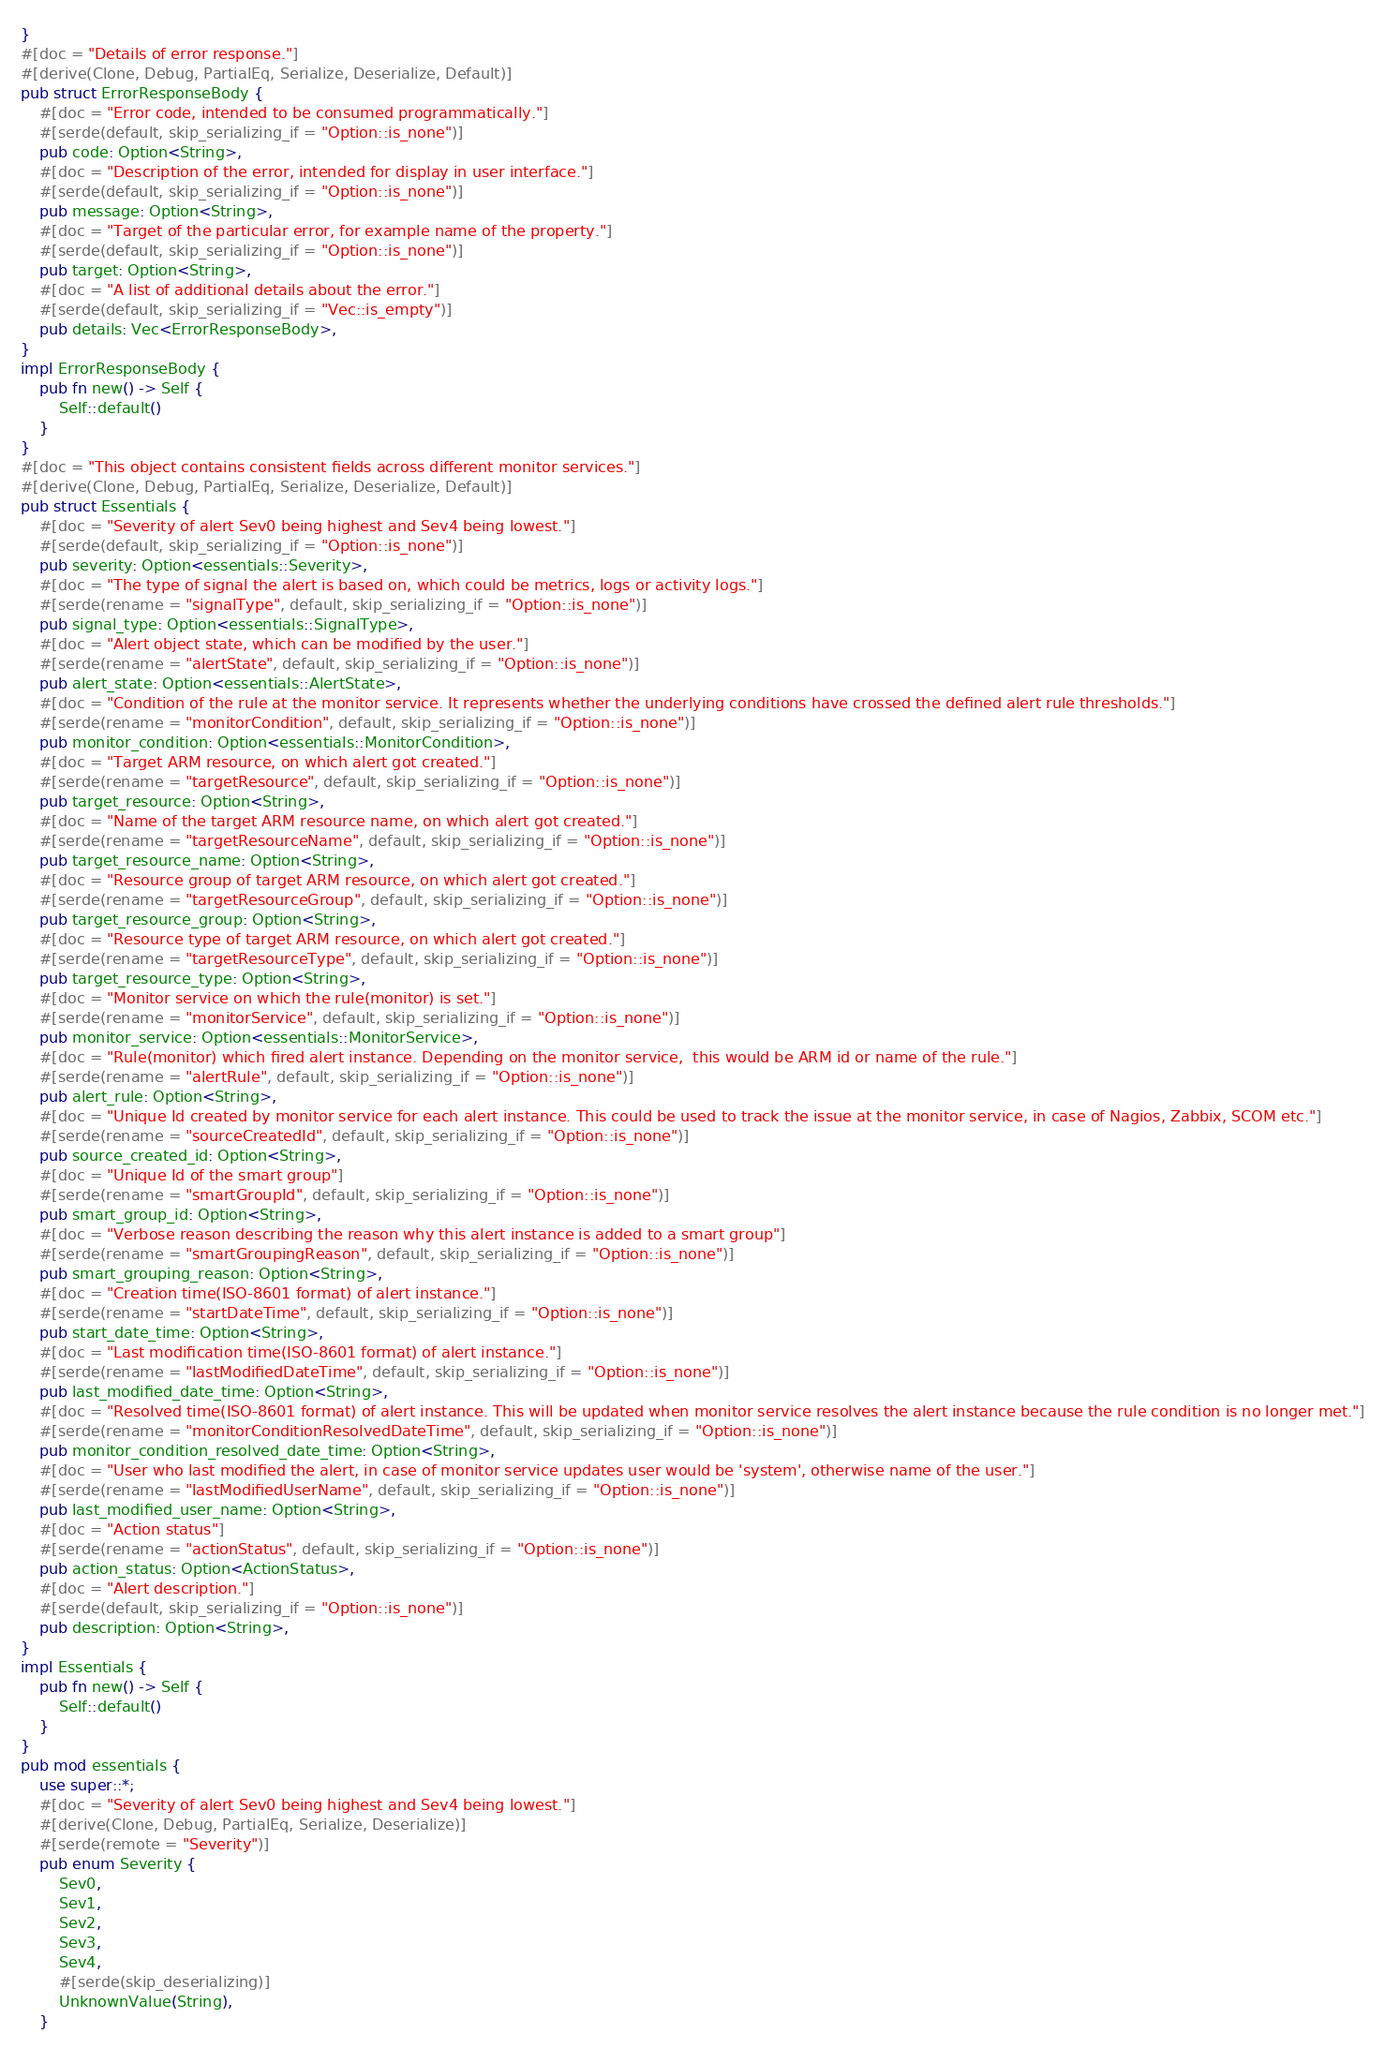<code> <loc_0><loc_0><loc_500><loc_500><_Rust_>}
#[doc = "Details of error response."]
#[derive(Clone, Debug, PartialEq, Serialize, Deserialize, Default)]
pub struct ErrorResponseBody {
    #[doc = "Error code, intended to be consumed programmatically."]
    #[serde(default, skip_serializing_if = "Option::is_none")]
    pub code: Option<String>,
    #[doc = "Description of the error, intended for display in user interface."]
    #[serde(default, skip_serializing_if = "Option::is_none")]
    pub message: Option<String>,
    #[doc = "Target of the particular error, for example name of the property."]
    #[serde(default, skip_serializing_if = "Option::is_none")]
    pub target: Option<String>,
    #[doc = "A list of additional details about the error."]
    #[serde(default, skip_serializing_if = "Vec::is_empty")]
    pub details: Vec<ErrorResponseBody>,
}
impl ErrorResponseBody {
    pub fn new() -> Self {
        Self::default()
    }
}
#[doc = "This object contains consistent fields across different monitor services."]
#[derive(Clone, Debug, PartialEq, Serialize, Deserialize, Default)]
pub struct Essentials {
    #[doc = "Severity of alert Sev0 being highest and Sev4 being lowest."]
    #[serde(default, skip_serializing_if = "Option::is_none")]
    pub severity: Option<essentials::Severity>,
    #[doc = "The type of signal the alert is based on, which could be metrics, logs or activity logs."]
    #[serde(rename = "signalType", default, skip_serializing_if = "Option::is_none")]
    pub signal_type: Option<essentials::SignalType>,
    #[doc = "Alert object state, which can be modified by the user."]
    #[serde(rename = "alertState", default, skip_serializing_if = "Option::is_none")]
    pub alert_state: Option<essentials::AlertState>,
    #[doc = "Condition of the rule at the monitor service. It represents whether the underlying conditions have crossed the defined alert rule thresholds."]
    #[serde(rename = "monitorCondition", default, skip_serializing_if = "Option::is_none")]
    pub monitor_condition: Option<essentials::MonitorCondition>,
    #[doc = "Target ARM resource, on which alert got created."]
    #[serde(rename = "targetResource", default, skip_serializing_if = "Option::is_none")]
    pub target_resource: Option<String>,
    #[doc = "Name of the target ARM resource name, on which alert got created."]
    #[serde(rename = "targetResourceName", default, skip_serializing_if = "Option::is_none")]
    pub target_resource_name: Option<String>,
    #[doc = "Resource group of target ARM resource, on which alert got created."]
    #[serde(rename = "targetResourceGroup", default, skip_serializing_if = "Option::is_none")]
    pub target_resource_group: Option<String>,
    #[doc = "Resource type of target ARM resource, on which alert got created."]
    #[serde(rename = "targetResourceType", default, skip_serializing_if = "Option::is_none")]
    pub target_resource_type: Option<String>,
    #[doc = "Monitor service on which the rule(monitor) is set."]
    #[serde(rename = "monitorService", default, skip_serializing_if = "Option::is_none")]
    pub monitor_service: Option<essentials::MonitorService>,
    #[doc = "Rule(monitor) which fired alert instance. Depending on the monitor service,  this would be ARM id or name of the rule."]
    #[serde(rename = "alertRule", default, skip_serializing_if = "Option::is_none")]
    pub alert_rule: Option<String>,
    #[doc = "Unique Id created by monitor service for each alert instance. This could be used to track the issue at the monitor service, in case of Nagios, Zabbix, SCOM etc."]
    #[serde(rename = "sourceCreatedId", default, skip_serializing_if = "Option::is_none")]
    pub source_created_id: Option<String>,
    #[doc = "Unique Id of the smart group"]
    #[serde(rename = "smartGroupId", default, skip_serializing_if = "Option::is_none")]
    pub smart_group_id: Option<String>,
    #[doc = "Verbose reason describing the reason why this alert instance is added to a smart group"]
    #[serde(rename = "smartGroupingReason", default, skip_serializing_if = "Option::is_none")]
    pub smart_grouping_reason: Option<String>,
    #[doc = "Creation time(ISO-8601 format) of alert instance."]
    #[serde(rename = "startDateTime", default, skip_serializing_if = "Option::is_none")]
    pub start_date_time: Option<String>,
    #[doc = "Last modification time(ISO-8601 format) of alert instance."]
    #[serde(rename = "lastModifiedDateTime", default, skip_serializing_if = "Option::is_none")]
    pub last_modified_date_time: Option<String>,
    #[doc = "Resolved time(ISO-8601 format) of alert instance. This will be updated when monitor service resolves the alert instance because the rule condition is no longer met."]
    #[serde(rename = "monitorConditionResolvedDateTime", default, skip_serializing_if = "Option::is_none")]
    pub monitor_condition_resolved_date_time: Option<String>,
    #[doc = "User who last modified the alert, in case of monitor service updates user would be 'system', otherwise name of the user."]
    #[serde(rename = "lastModifiedUserName", default, skip_serializing_if = "Option::is_none")]
    pub last_modified_user_name: Option<String>,
    #[doc = "Action status"]
    #[serde(rename = "actionStatus", default, skip_serializing_if = "Option::is_none")]
    pub action_status: Option<ActionStatus>,
    #[doc = "Alert description."]
    #[serde(default, skip_serializing_if = "Option::is_none")]
    pub description: Option<String>,
}
impl Essentials {
    pub fn new() -> Self {
        Self::default()
    }
}
pub mod essentials {
    use super::*;
    #[doc = "Severity of alert Sev0 being highest and Sev4 being lowest."]
    #[derive(Clone, Debug, PartialEq, Serialize, Deserialize)]
    #[serde(remote = "Severity")]
    pub enum Severity {
        Sev0,
        Sev1,
        Sev2,
        Sev3,
        Sev4,
        #[serde(skip_deserializing)]
        UnknownValue(String),
    }</code> 